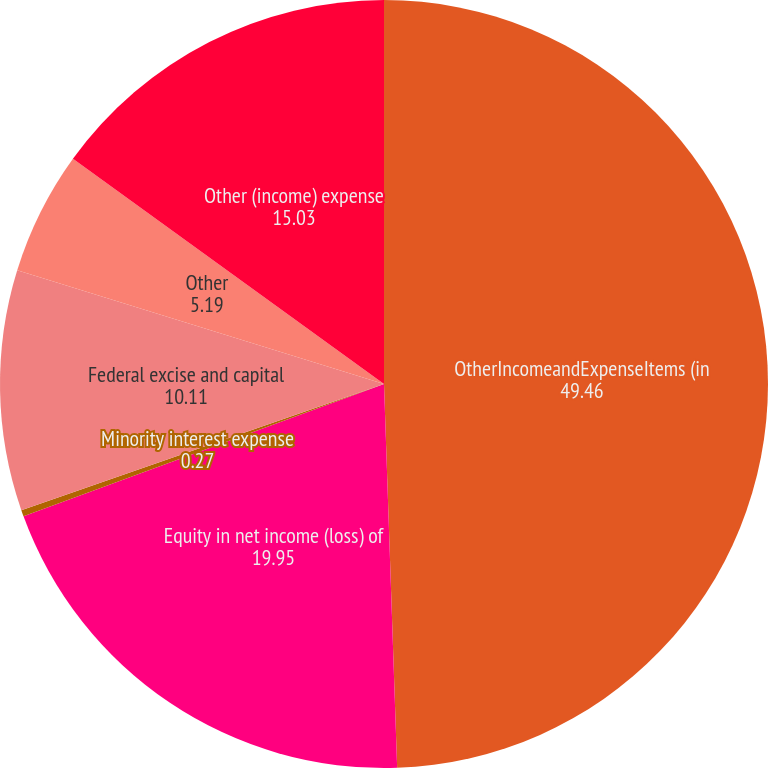<chart> <loc_0><loc_0><loc_500><loc_500><pie_chart><fcel>OtherIncomeandExpenseItems (in<fcel>Equity in net income (loss) of<fcel>Minority interest expense<fcel>Federal excise and capital<fcel>Other<fcel>Other (income) expense<nl><fcel>49.46%<fcel>19.95%<fcel>0.27%<fcel>10.11%<fcel>5.19%<fcel>15.03%<nl></chart> 